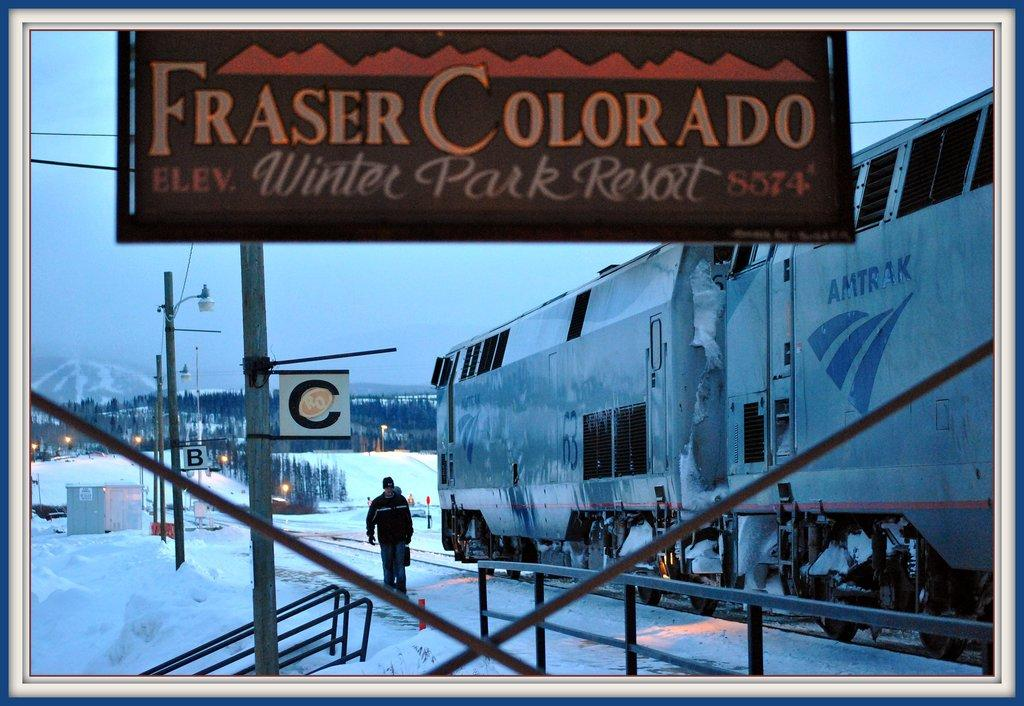<image>
Provide a brief description of the given image. a sign that says 'fraser colorado' on it 